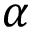Convert formula to latex. <formula><loc_0><loc_0><loc_500><loc_500>\alpha</formula> 